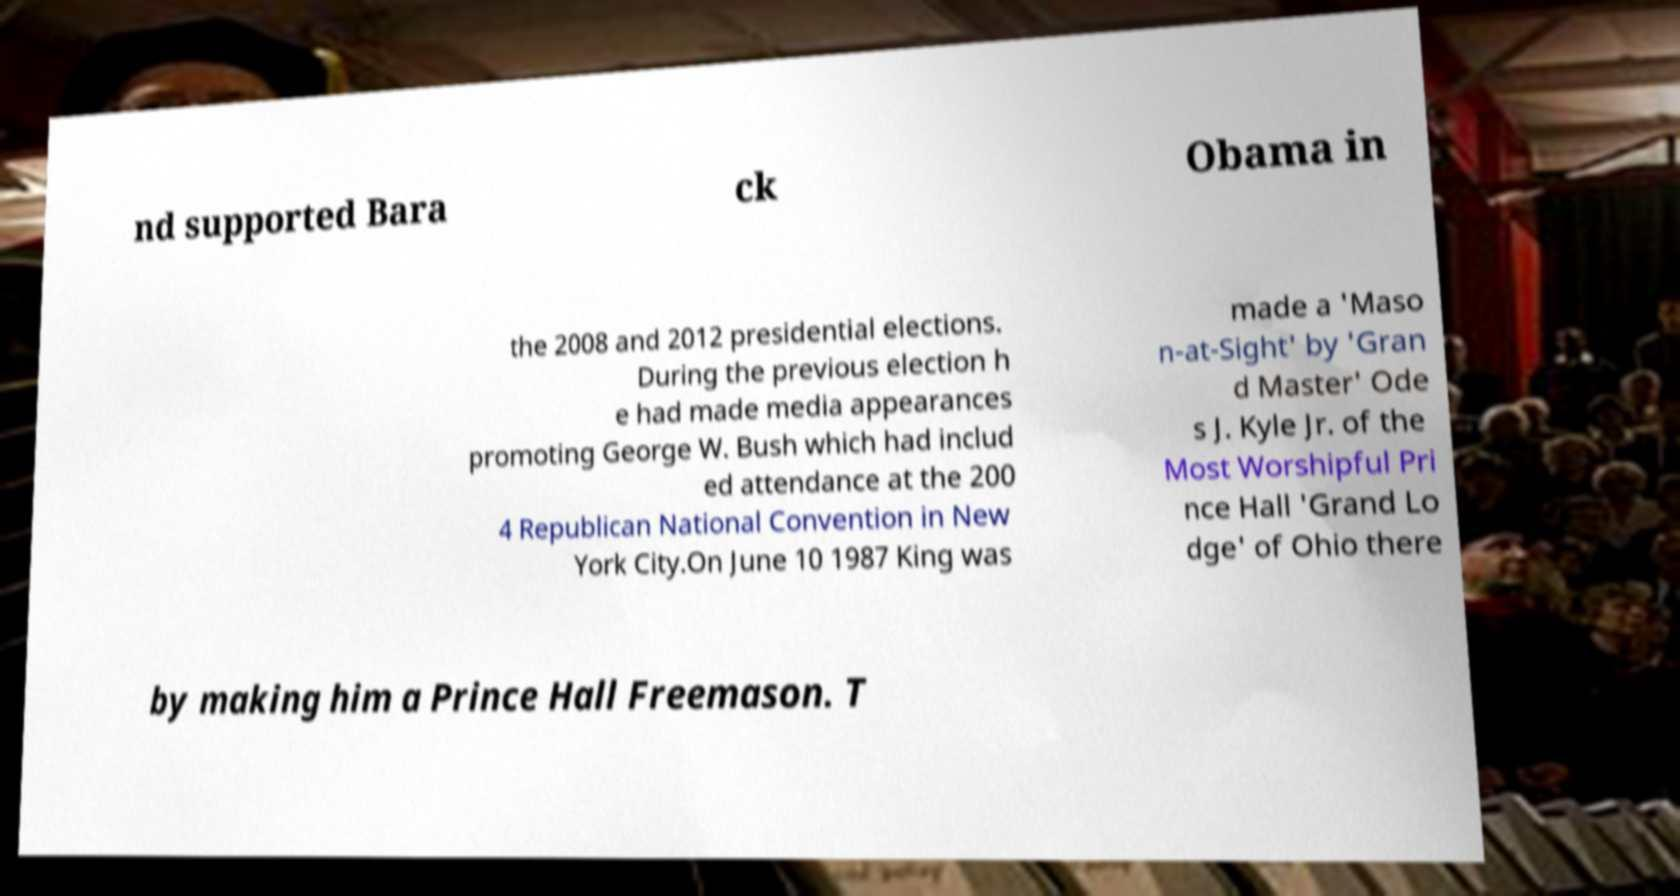I need the written content from this picture converted into text. Can you do that? nd supported Bara ck Obama in the 2008 and 2012 presidential elections. During the previous election h e had made media appearances promoting George W. Bush which had includ ed attendance at the 200 4 Republican National Convention in New York City.On June 10 1987 King was made a 'Maso n-at-Sight' by 'Gran d Master' Ode s J. Kyle Jr. of the Most Worshipful Pri nce Hall 'Grand Lo dge' of Ohio there by making him a Prince Hall Freemason. T 